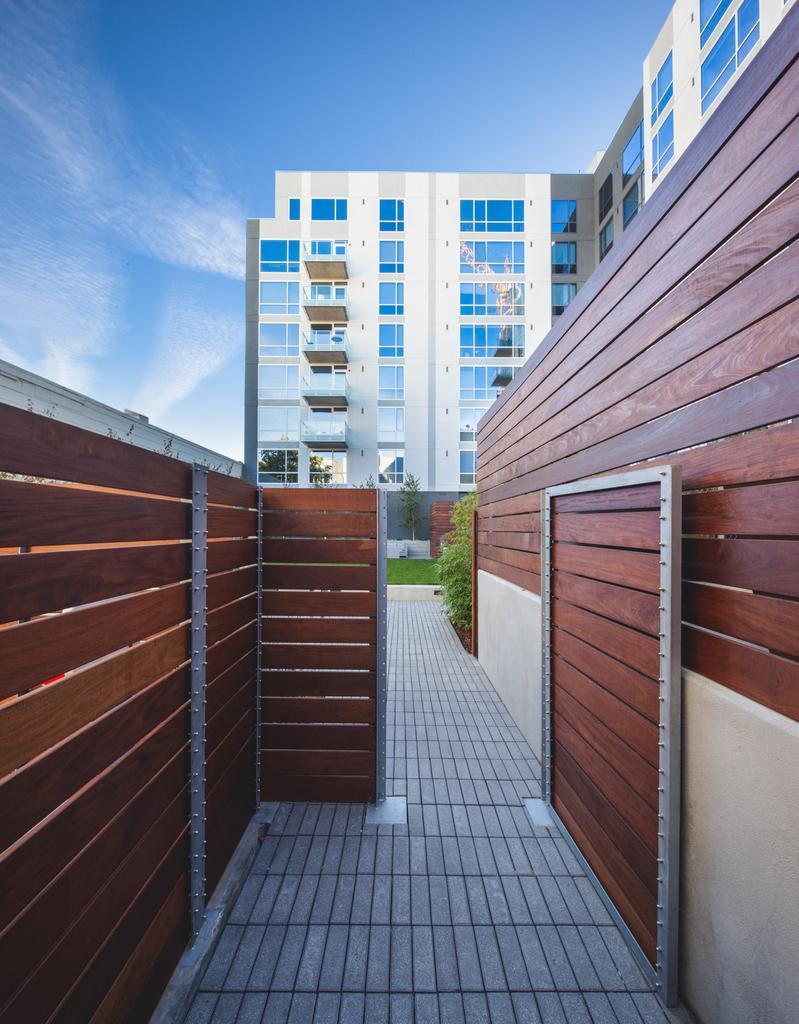In one or two sentences, can you explain what this image depicts? In this image, at the middle there is a path and a way, at the left side there is a brown color wooden wall, at the background there is a building and at the top there is a blue color sky. 